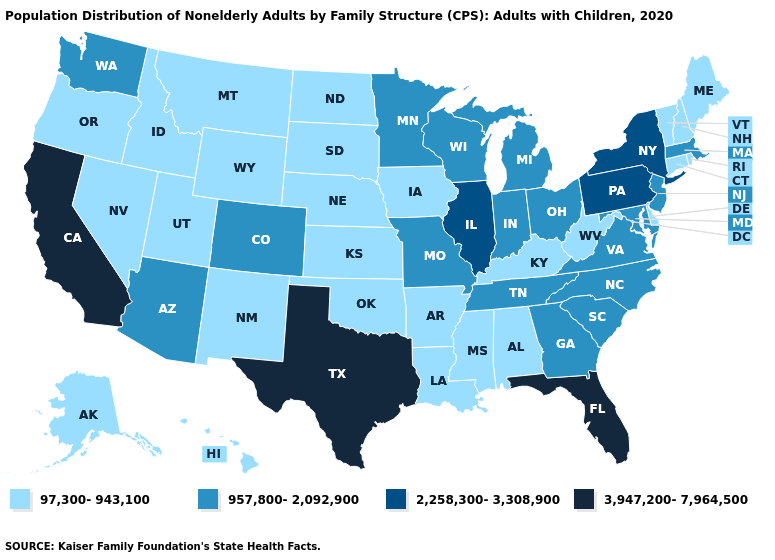Does the first symbol in the legend represent the smallest category?
Keep it brief. Yes. Does Kentucky have a lower value than Virginia?
Concise answer only. Yes. Does California have the highest value in the USA?
Give a very brief answer. Yes. Name the states that have a value in the range 957,800-2,092,900?
Give a very brief answer. Arizona, Colorado, Georgia, Indiana, Maryland, Massachusetts, Michigan, Minnesota, Missouri, New Jersey, North Carolina, Ohio, South Carolina, Tennessee, Virginia, Washington, Wisconsin. What is the lowest value in states that border Pennsylvania?
Be succinct. 97,300-943,100. Does Montana have a lower value than Georgia?
Write a very short answer. Yes. Among the states that border Virginia , which have the lowest value?
Answer briefly. Kentucky, West Virginia. Name the states that have a value in the range 3,947,200-7,964,500?
Be succinct. California, Florida, Texas. Does the first symbol in the legend represent the smallest category?
Concise answer only. Yes. Which states have the lowest value in the MidWest?
Short answer required. Iowa, Kansas, Nebraska, North Dakota, South Dakota. What is the highest value in states that border New Hampshire?
Answer briefly. 957,800-2,092,900. Name the states that have a value in the range 3,947,200-7,964,500?
Short answer required. California, Florida, Texas. What is the highest value in the Northeast ?
Write a very short answer. 2,258,300-3,308,900. What is the value of Pennsylvania?
Write a very short answer. 2,258,300-3,308,900. What is the value of Missouri?
Concise answer only. 957,800-2,092,900. 